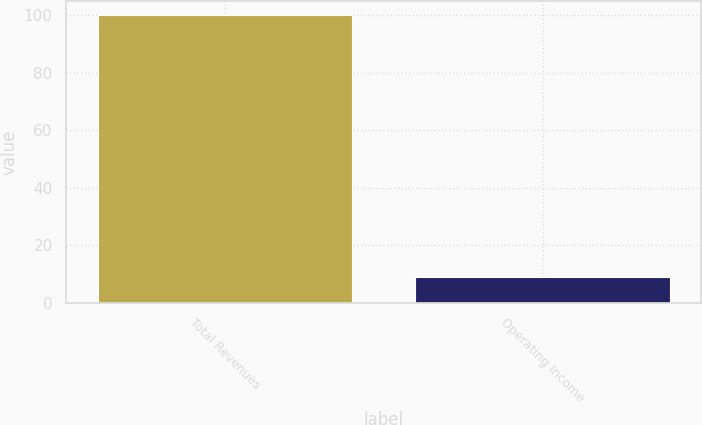Convert chart to OTSL. <chart><loc_0><loc_0><loc_500><loc_500><bar_chart><fcel>Total Revenues<fcel>Operating Income<nl><fcel>100<fcel>9<nl></chart> 